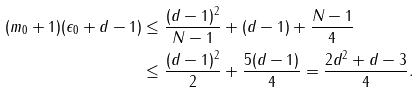<formula> <loc_0><loc_0><loc_500><loc_500>( m _ { 0 } + 1 ) ( \epsilon _ { 0 } + d - 1 ) & \leq \frac { ( d - 1 ) ^ { 2 } } { N - 1 } + ( d - 1 ) + \frac { N - 1 } { 4 } \\ & \leq \frac { ( d - 1 ) ^ { 2 } } { 2 } + \frac { 5 ( d - 1 ) } { 4 } = \frac { 2 d ^ { 2 } + d - 3 } { 4 } .</formula> 